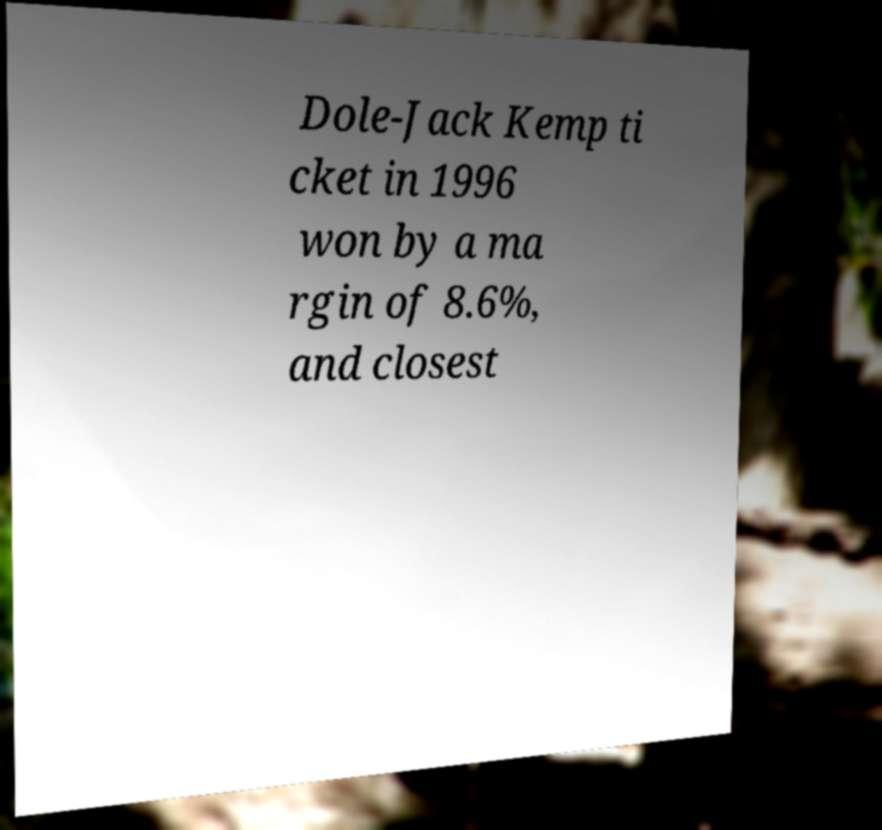Can you accurately transcribe the text from the provided image for me? Dole-Jack Kemp ti cket in 1996 won by a ma rgin of 8.6%, and closest 